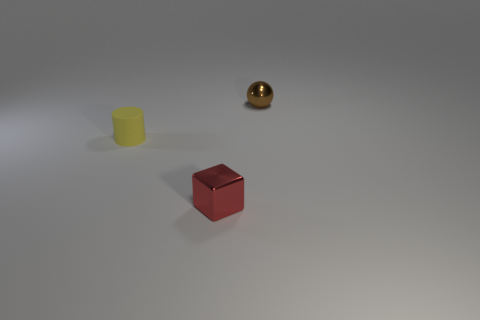How many tiny yellow matte things have the same shape as the red metal object?
Ensure brevity in your answer.  0. Is the color of the tiny cylinder the same as the metal cube?
Your response must be concise. No. Is the number of small balls less than the number of gray matte blocks?
Offer a very short reply. No. There is a object behind the matte thing; what is its material?
Ensure brevity in your answer.  Metal. What is the material of the yellow thing that is the same size as the metallic sphere?
Offer a terse response. Rubber. What material is the thing in front of the thing that is to the left of the shiny thing that is in front of the brown metallic sphere?
Offer a terse response. Metal. Does the thing that is behind the cylinder have the same size as the small red metal thing?
Offer a very short reply. Yes. Is the number of tiny yellow matte objects greater than the number of large red rubber spheres?
Your answer should be very brief. Yes. What number of big things are either brown objects or metallic things?
Make the answer very short. 0. What number of tiny cyan cubes are made of the same material as the sphere?
Make the answer very short. 0. 